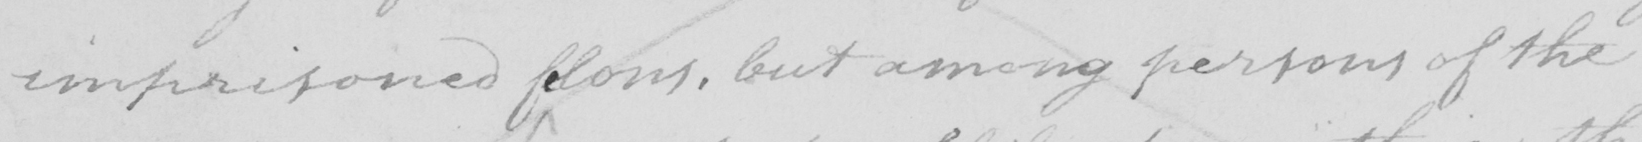What does this handwritten line say? imprisoned felons , but among persons of the 